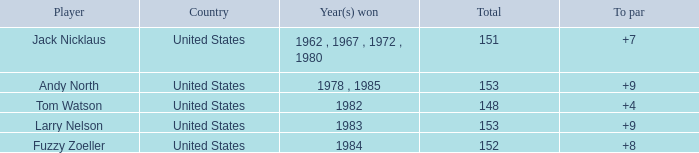What is the To par of Player Andy North with a Total larger than 153? 0.0. Give me the full table as a dictionary. {'header': ['Player', 'Country', 'Year(s) won', 'Total', 'To par'], 'rows': [['Jack Nicklaus', 'United States', '1962 , 1967 , 1972 , 1980', '151', '+7'], ['Andy North', 'United States', '1978 , 1985', '153', '+9'], ['Tom Watson', 'United States', '1982', '148', '+4'], ['Larry Nelson', 'United States', '1983', '153', '+9'], ['Fuzzy Zoeller', 'United States', '1984', '152', '+8']]} 